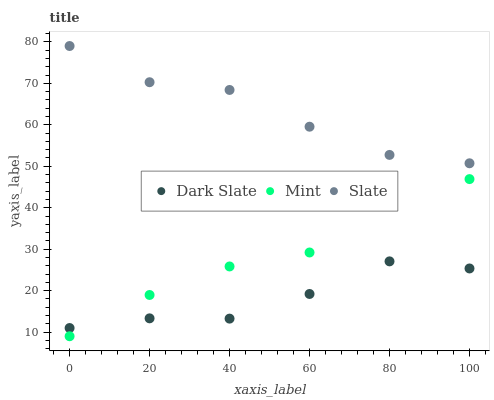Does Dark Slate have the minimum area under the curve?
Answer yes or no. Yes. Does Slate have the maximum area under the curve?
Answer yes or no. Yes. Does Mint have the minimum area under the curve?
Answer yes or no. No. Does Mint have the maximum area under the curve?
Answer yes or no. No. Is Mint the smoothest?
Answer yes or no. Yes. Is Slate the roughest?
Answer yes or no. Yes. Is Slate the smoothest?
Answer yes or no. No. Is Mint the roughest?
Answer yes or no. No. Does Mint have the lowest value?
Answer yes or no. Yes. Does Slate have the lowest value?
Answer yes or no. No. Does Slate have the highest value?
Answer yes or no. Yes. Does Mint have the highest value?
Answer yes or no. No. Is Dark Slate less than Slate?
Answer yes or no. Yes. Is Slate greater than Dark Slate?
Answer yes or no. Yes. Does Dark Slate intersect Mint?
Answer yes or no. Yes. Is Dark Slate less than Mint?
Answer yes or no. No. Is Dark Slate greater than Mint?
Answer yes or no. No. Does Dark Slate intersect Slate?
Answer yes or no. No. 